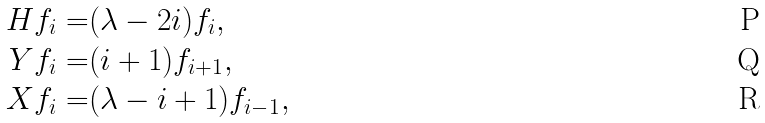Convert formula to latex. <formula><loc_0><loc_0><loc_500><loc_500>H f _ { i } = & ( \lambda - 2 i ) f _ { i } , \\ Y f _ { i } = & ( i + 1 ) f _ { i + 1 } , \\ X f _ { i } = & ( \lambda - i + 1 ) f _ { i - 1 } ,</formula> 